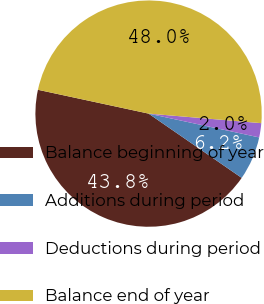Convert chart to OTSL. <chart><loc_0><loc_0><loc_500><loc_500><pie_chart><fcel>Balance beginning of year<fcel>Additions during period<fcel>Deductions during period<fcel>Balance end of year<nl><fcel>43.76%<fcel>6.24%<fcel>2.03%<fcel>47.97%<nl></chart> 